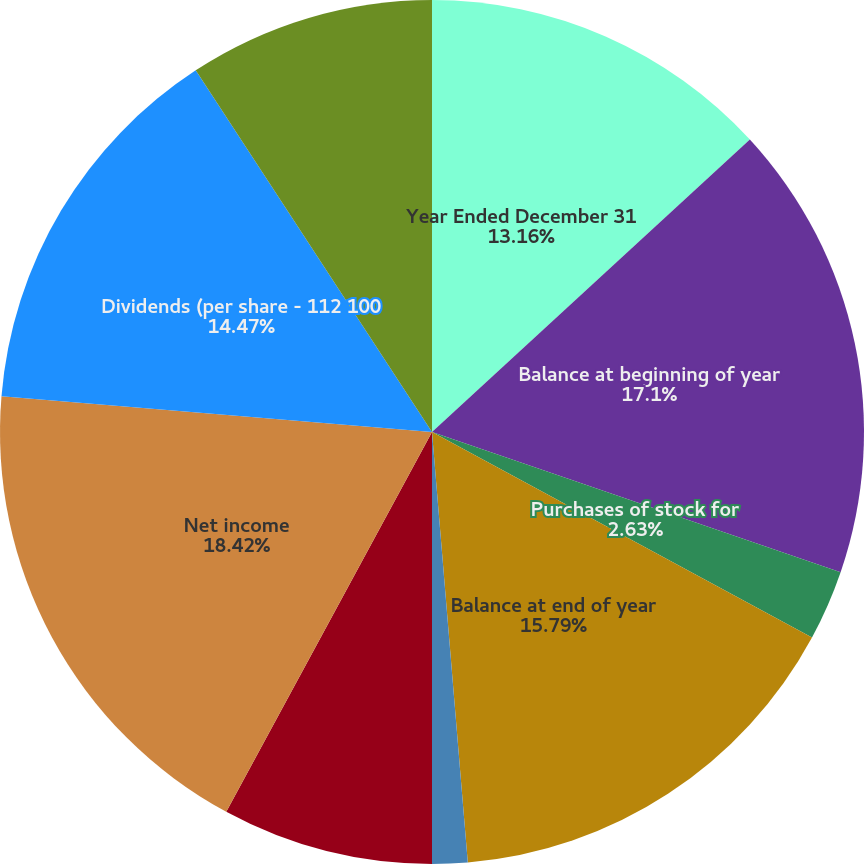Convert chart to OTSL. <chart><loc_0><loc_0><loc_500><loc_500><pie_chart><fcel>Year Ended December 31<fcel>Balance at beginning of year<fcel>Stock issued to employees<fcel>Purchases of stock for<fcel>Balance at end of year<fcel>Tax benefit from employees'<fcel>Stock-based compensation<fcel>Net income<fcel>Dividends (per share - 112 100<fcel>Net foreign currency<nl><fcel>13.16%<fcel>17.1%<fcel>0.0%<fcel>2.63%<fcel>15.79%<fcel>1.32%<fcel>7.9%<fcel>18.42%<fcel>14.47%<fcel>9.21%<nl></chart> 